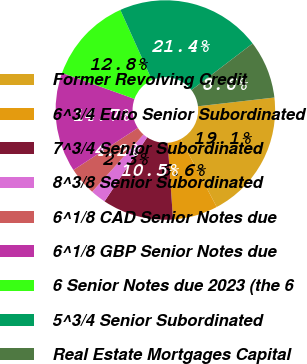<chart> <loc_0><loc_0><loc_500><loc_500><pie_chart><fcel>Former Revolving Credit<fcel>6^3/4 Euro Senior Subordinated<fcel>7^3/4 Senior Subordinated<fcel>8^3/8 Senior Subordinated<fcel>6^1/8 CAD Senior Notes due<fcel>6^1/8 GBP Senior Notes due<fcel>6 Senior Notes due 2023 (the 6<fcel>5^3/4 Senior Subordinated<fcel>Real Estate Mortgages Capital<nl><fcel>19.06%<fcel>6.64%<fcel>10.46%<fcel>2.27%<fcel>4.18%<fcel>14.69%<fcel>12.78%<fcel>21.36%<fcel>8.55%<nl></chart> 